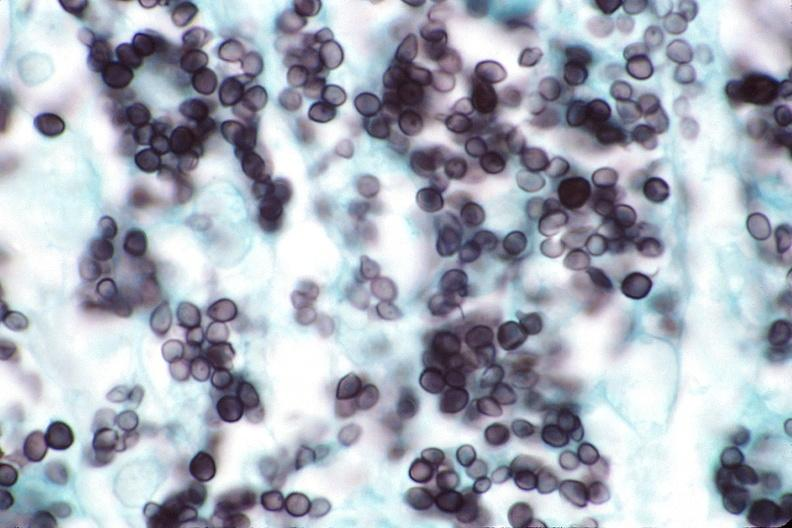what does this image show?
Answer the question using a single word or phrase. Lung 